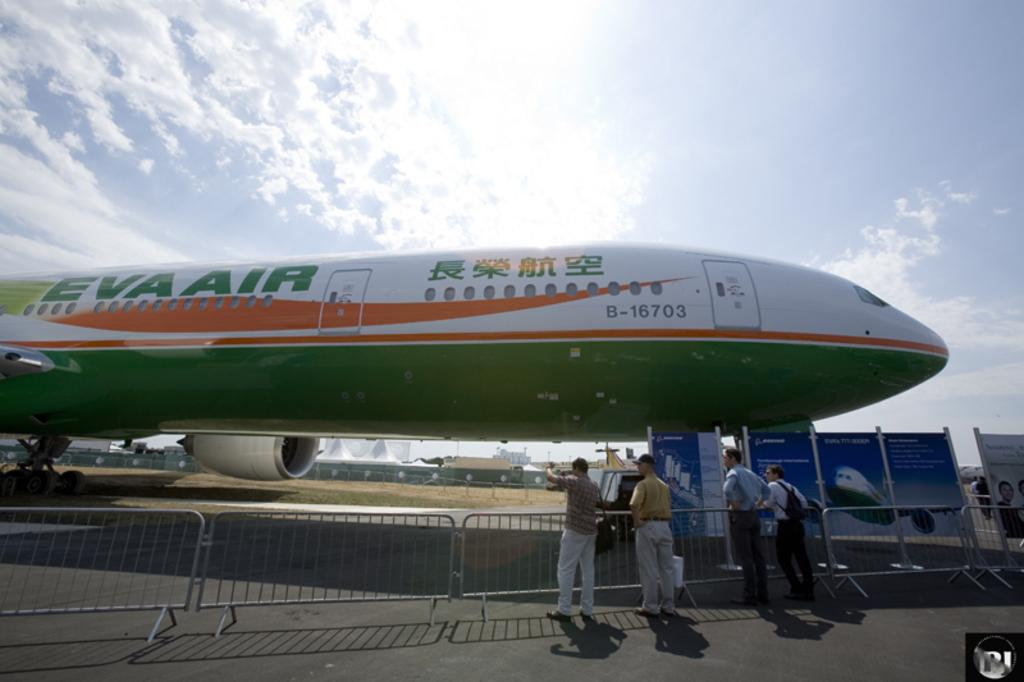What is the main subject of the image? The main subject of the image is a plane. What colors can be seen on the plane? The plane has green, white, and orange colors. What structure is visible in the image besides the plane? There is a fence gate in the image. Who or what can be seen near the fence gate? There are people standing beside the fence gate. What holiday is being celebrated in the image? There is no indication of a holiday being celebrated in the image. What type of territory is depicted in the image? There is no territory or specific location depicted in the image. 